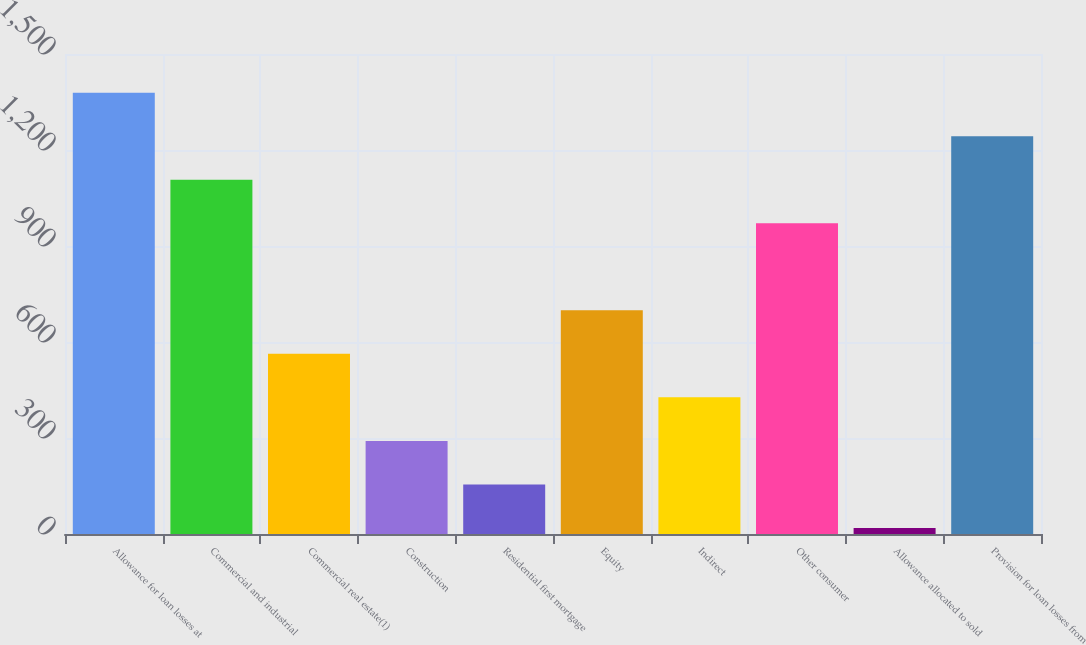Convert chart. <chart><loc_0><loc_0><loc_500><loc_500><bar_chart><fcel>Allowance for loan losses at<fcel>Commercial and industrial<fcel>Commercial real estate(1)<fcel>Construction<fcel>Residential first mortgage<fcel>Equity<fcel>Indirect<fcel>Other consumer<fcel>Allowance allocated to sold<fcel>Provision for loan losses from<nl><fcel>1379<fcel>1107<fcel>563<fcel>291<fcel>155<fcel>699<fcel>427<fcel>971<fcel>19<fcel>1243<nl></chart> 